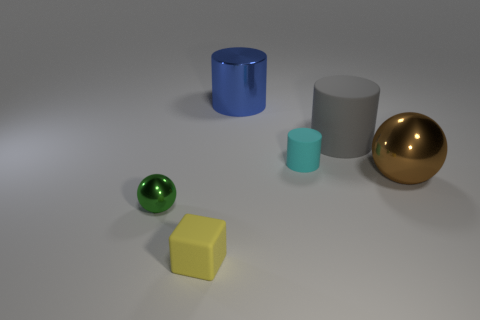Add 2 blue shiny objects. How many objects exist? 8 Subtract all cyan rubber cylinders. How many cylinders are left? 2 Add 3 green shiny cylinders. How many green shiny cylinders exist? 3 Subtract all brown spheres. How many spheres are left? 1 Subtract 1 brown balls. How many objects are left? 5 Subtract all spheres. How many objects are left? 4 Subtract 1 cylinders. How many cylinders are left? 2 Subtract all cyan spheres. Subtract all red cylinders. How many spheres are left? 2 Subtract all gray cylinders. How many blue spheres are left? 0 Subtract all big blue cylinders. Subtract all small cyan rubber cylinders. How many objects are left? 4 